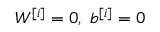Convert formula to latex. <formula><loc_0><loc_0><loc_500><loc_500>W ^ { [ i ] } = 0 , \ b ^ { [ i ] } = 0</formula> 